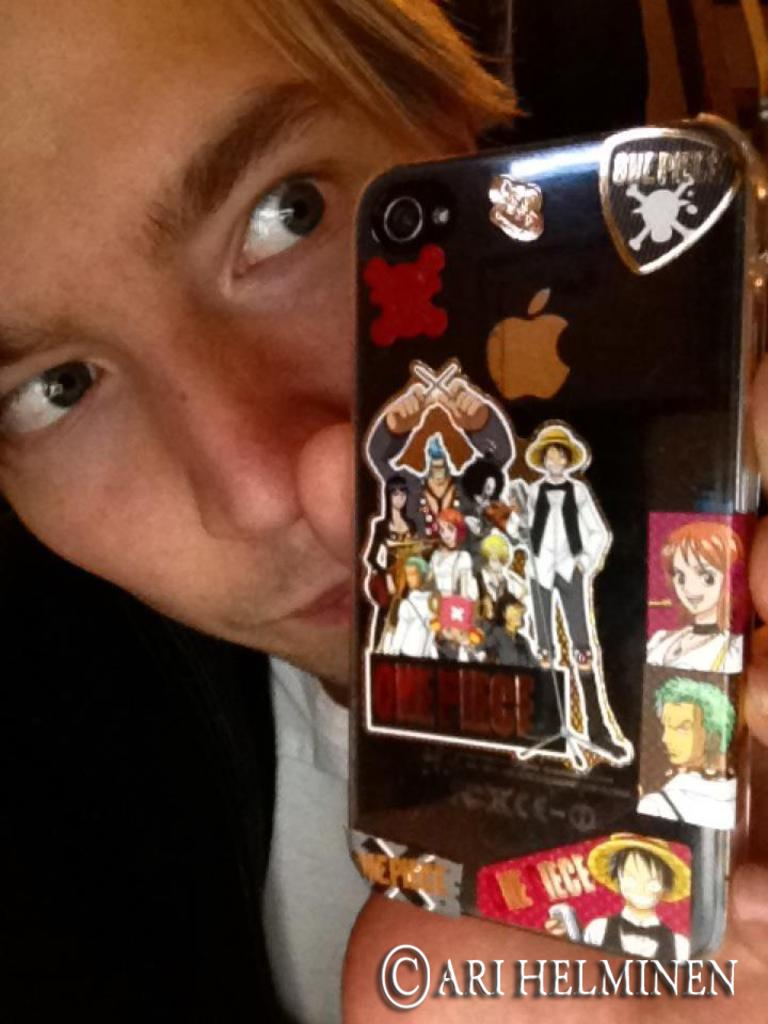Who is the main subject in the image? There is a boy in the image. What is the boy wearing? The boy is wearing a white t-shirt and a black jacket. What is the boy holding in his hand? The boy is holding a mobile case in his hand. What can be seen on the mobile case? There are stickers on the mobile case. What is the boy's focus in the image? The boy is looking at the mobile case. Can you tell me where the drain is located in the image? There is no drain present in the image. What type of garden can be seen in the background of the image? There is no garden present in the image. 